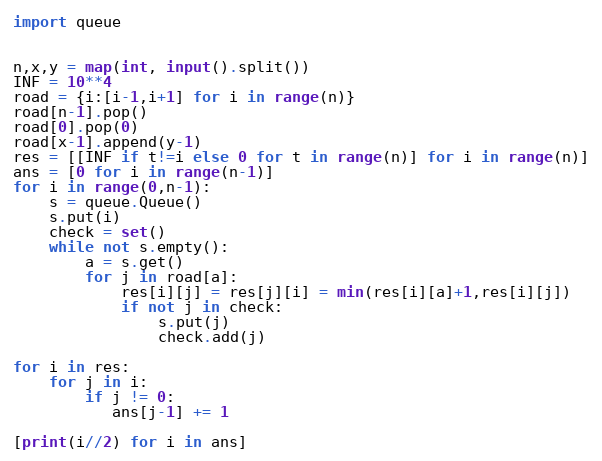<code> <loc_0><loc_0><loc_500><loc_500><_Python_>import queue


n,x,y = map(int, input().split())
INF = 10**4
road = {i:[i-1,i+1] for i in range(n)}
road[n-1].pop()
road[0].pop(0)
road[x-1].append(y-1)
res = [[INF if t!=i else 0 for t in range(n)] for i in range(n)]
ans = [0 for i in range(n-1)]
for i in range(0,n-1):
    s = queue.Queue()
    s.put(i)
    check = set()
    while not s.empty():
        a = s.get()
        for j in road[a]:
            res[i][j] = res[j][i] = min(res[i][a]+1,res[i][j])
            if not j in check:
                s.put(j)
                check.add(j)

for i in res:
    for j in i:
        if j != 0:
           ans[j-1] += 1

[print(i//2) for i in ans]</code> 